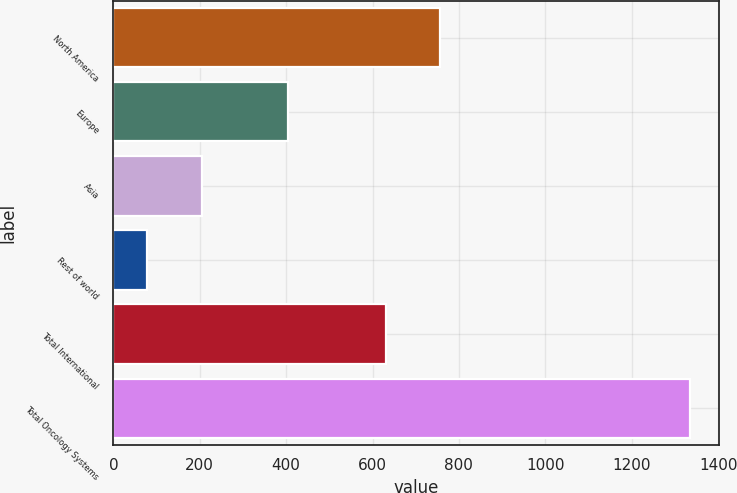Convert chart. <chart><loc_0><loc_0><loc_500><loc_500><bar_chart><fcel>North America<fcel>Europe<fcel>Asia<fcel>Rest of world<fcel>Total International<fcel>Total Oncology Systems<nl><fcel>756.7<fcel>404<fcel>204.7<fcel>79<fcel>631<fcel>1336<nl></chart> 